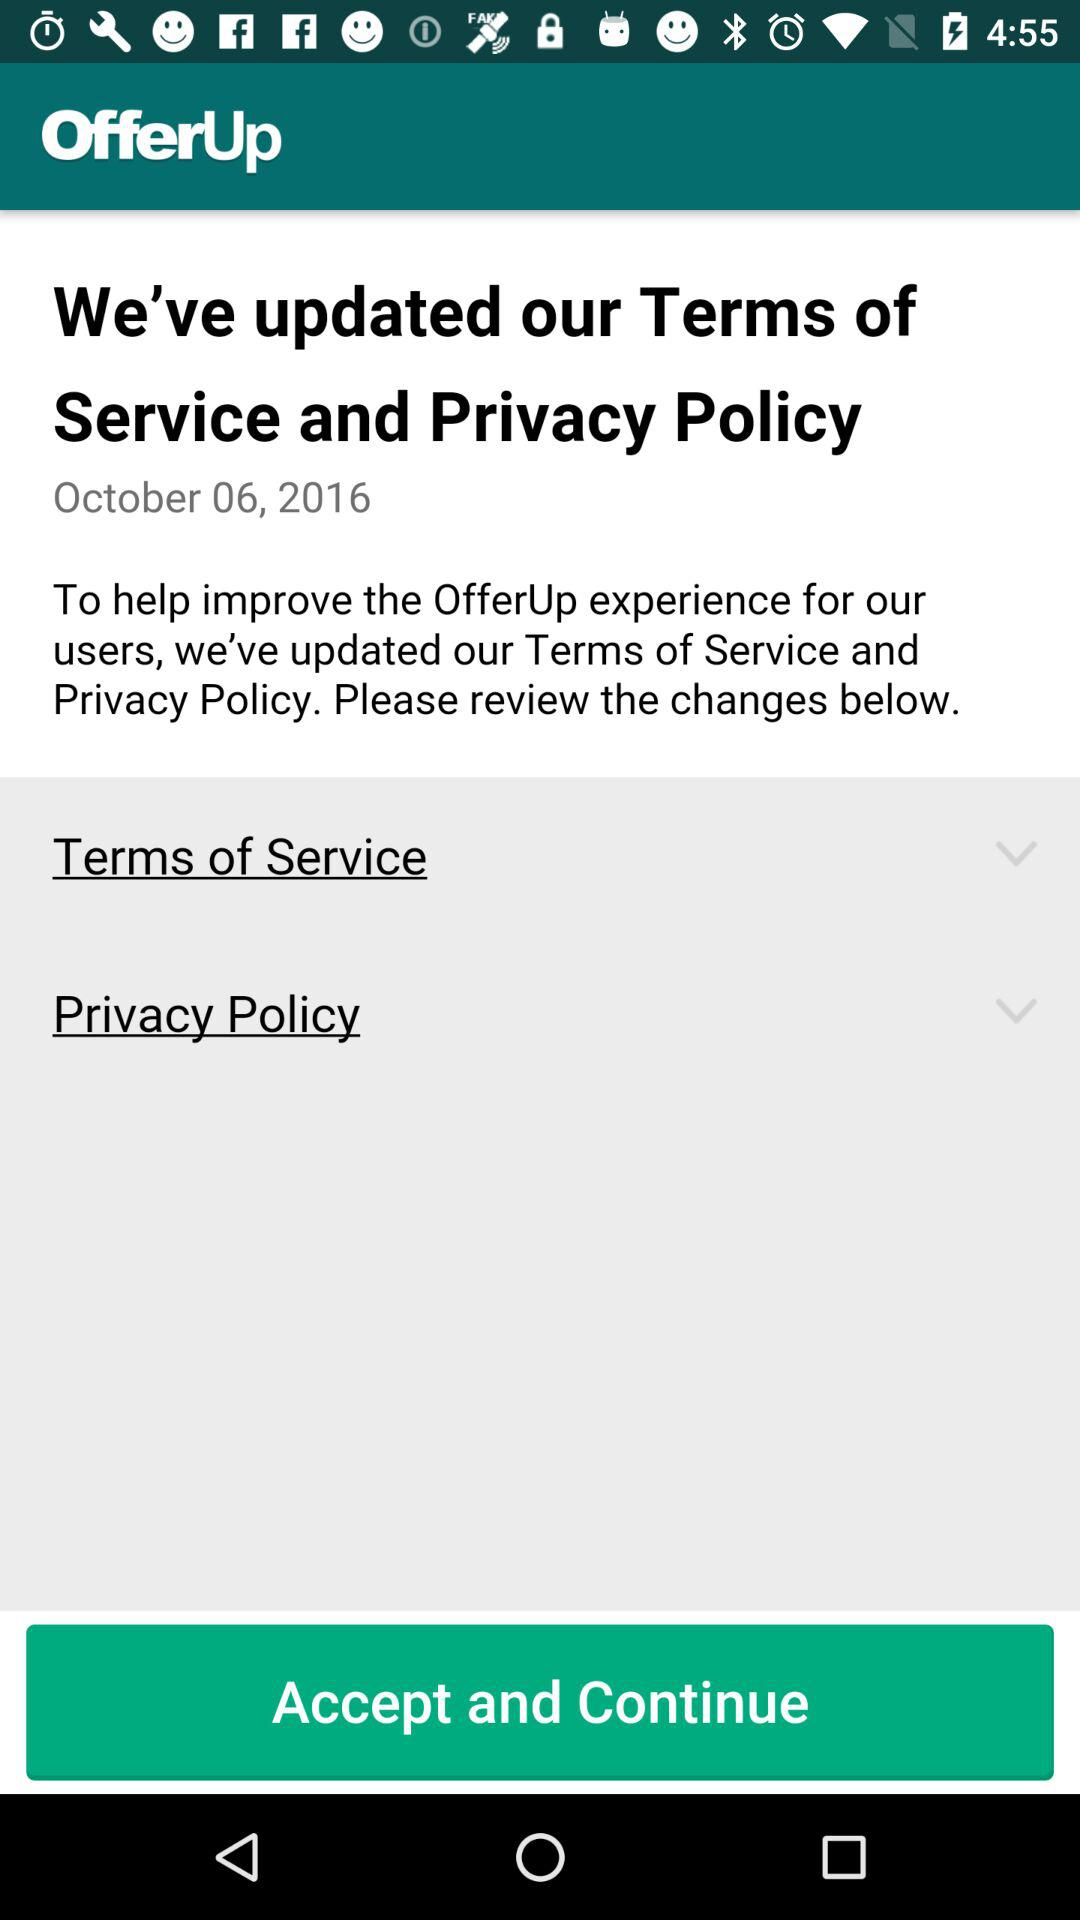What is the name of the application? The name of the application is "OfferUp". 